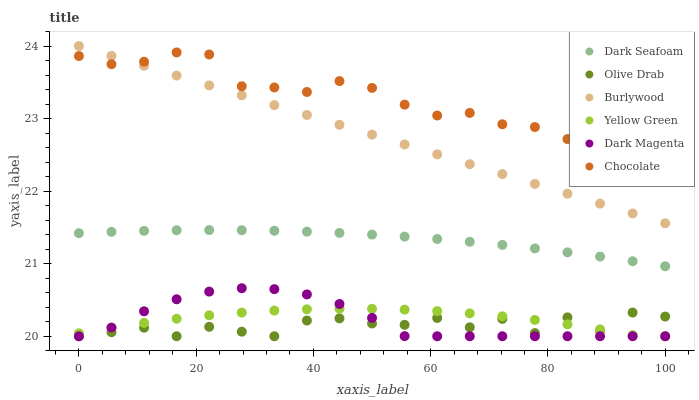Does Olive Drab have the minimum area under the curve?
Answer yes or no. Yes. Does Chocolate have the maximum area under the curve?
Answer yes or no. Yes. Does Burlywood have the minimum area under the curve?
Answer yes or no. No. Does Burlywood have the maximum area under the curve?
Answer yes or no. No. Is Burlywood the smoothest?
Answer yes or no. Yes. Is Olive Drab the roughest?
Answer yes or no. Yes. Is Chocolate the smoothest?
Answer yes or no. No. Is Chocolate the roughest?
Answer yes or no. No. Does Yellow Green have the lowest value?
Answer yes or no. Yes. Does Burlywood have the lowest value?
Answer yes or no. No. Does Burlywood have the highest value?
Answer yes or no. Yes. Does Chocolate have the highest value?
Answer yes or no. No. Is Dark Magenta less than Chocolate?
Answer yes or no. Yes. Is Burlywood greater than Dark Seafoam?
Answer yes or no. Yes. Does Burlywood intersect Chocolate?
Answer yes or no. Yes. Is Burlywood less than Chocolate?
Answer yes or no. No. Is Burlywood greater than Chocolate?
Answer yes or no. No. Does Dark Magenta intersect Chocolate?
Answer yes or no. No. 